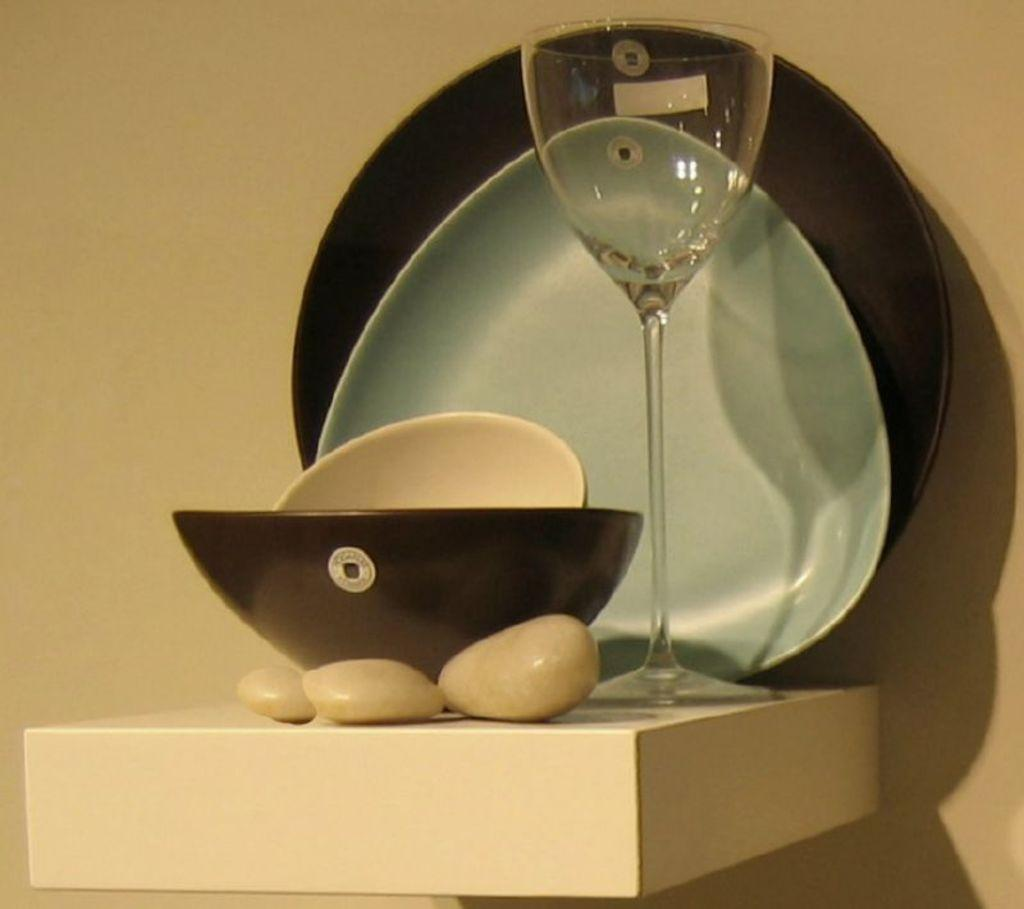What is in the bowl that is visible in the image? There is no specific information about the contents of the bowl in the provided facts. Besides the bowl, what other objects can be seen in the image? There are stones, plates, and a glass visible in the image. Where are these objects located in the image? The objects are on a table in the image. What can be seen in the background of the image? There is a wall in the background of the image. What type of grain is being used by the organization in the image? There is no mention of grain, organization, or any related activities in the image. 